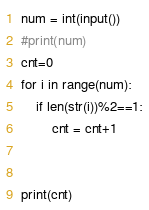Convert code to text. <code><loc_0><loc_0><loc_500><loc_500><_Python_>num = int(input())
#print(num)
cnt=0
for i in range(num):
    if len(str(i))%2==1:
        cnt = cnt+1
    
        
print(cnt)</code> 